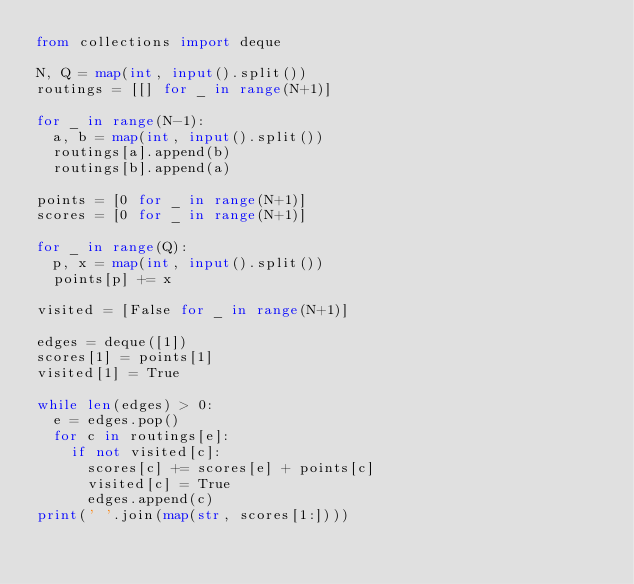Convert code to text. <code><loc_0><loc_0><loc_500><loc_500><_Python_>from collections import deque

N, Q = map(int, input().split())
routings = [[] for _ in range(N+1)]

for _ in range(N-1):
  a, b = map(int, input().split())
  routings[a].append(b)
  routings[b].append(a)

points = [0 for _ in range(N+1)]
scores = [0 for _ in range(N+1)]

for _ in range(Q):
  p, x = map(int, input().split())
  points[p] += x

visited = [False for _ in range(N+1)]
  
edges = deque([1])
scores[1] = points[1]
visited[1] = True

while len(edges) > 0: 
  e = edges.pop()
  for c in routings[e]:
    if not visited[c]:
      scores[c] += scores[e] + points[c]
      visited[c] = True
      edges.append(c)
print(' '.join(map(str, scores[1:])))
  
</code> 